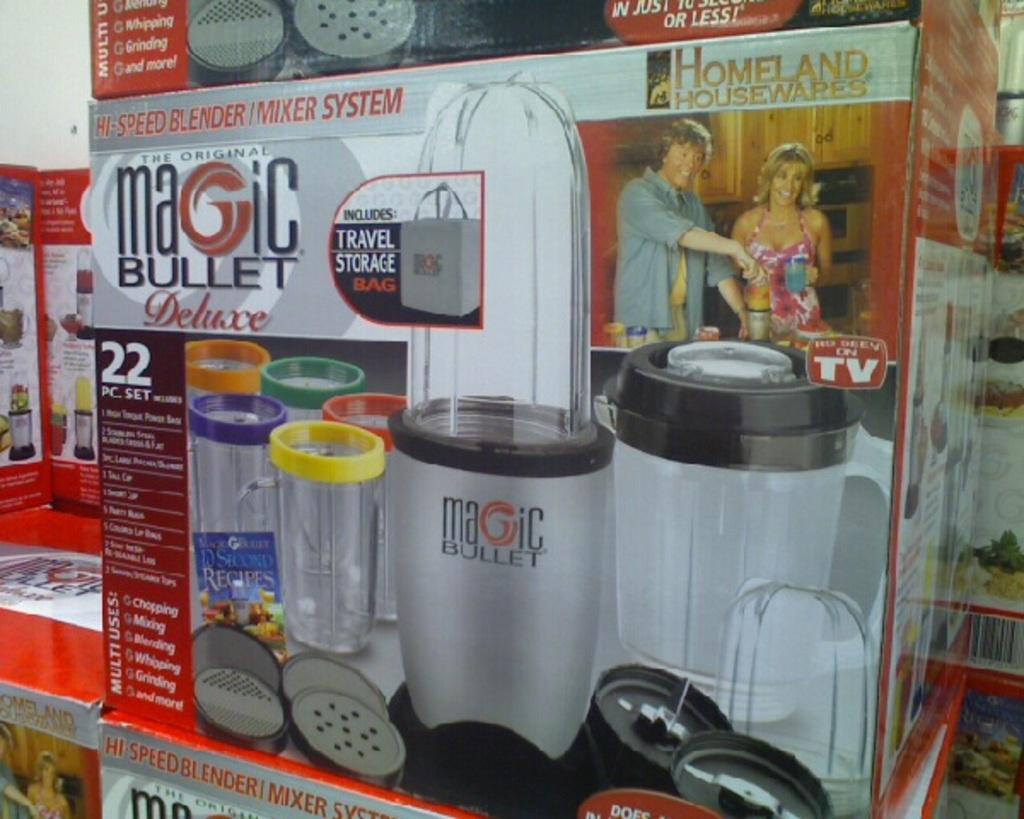What product is that?
Ensure brevity in your answer.  Magic bullet. What is the product that is advertised on the box?
Make the answer very short. Magic bullet. 